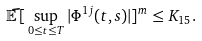<formula> <loc_0><loc_0><loc_500><loc_500>\mathbb { \tilde { E } } \, [ \, \sup _ { 0 \leq t \leq T } | \Phi ^ { 1 j } ( t , s ) | ] ^ { m } \leq K _ { 1 5 } .</formula> 